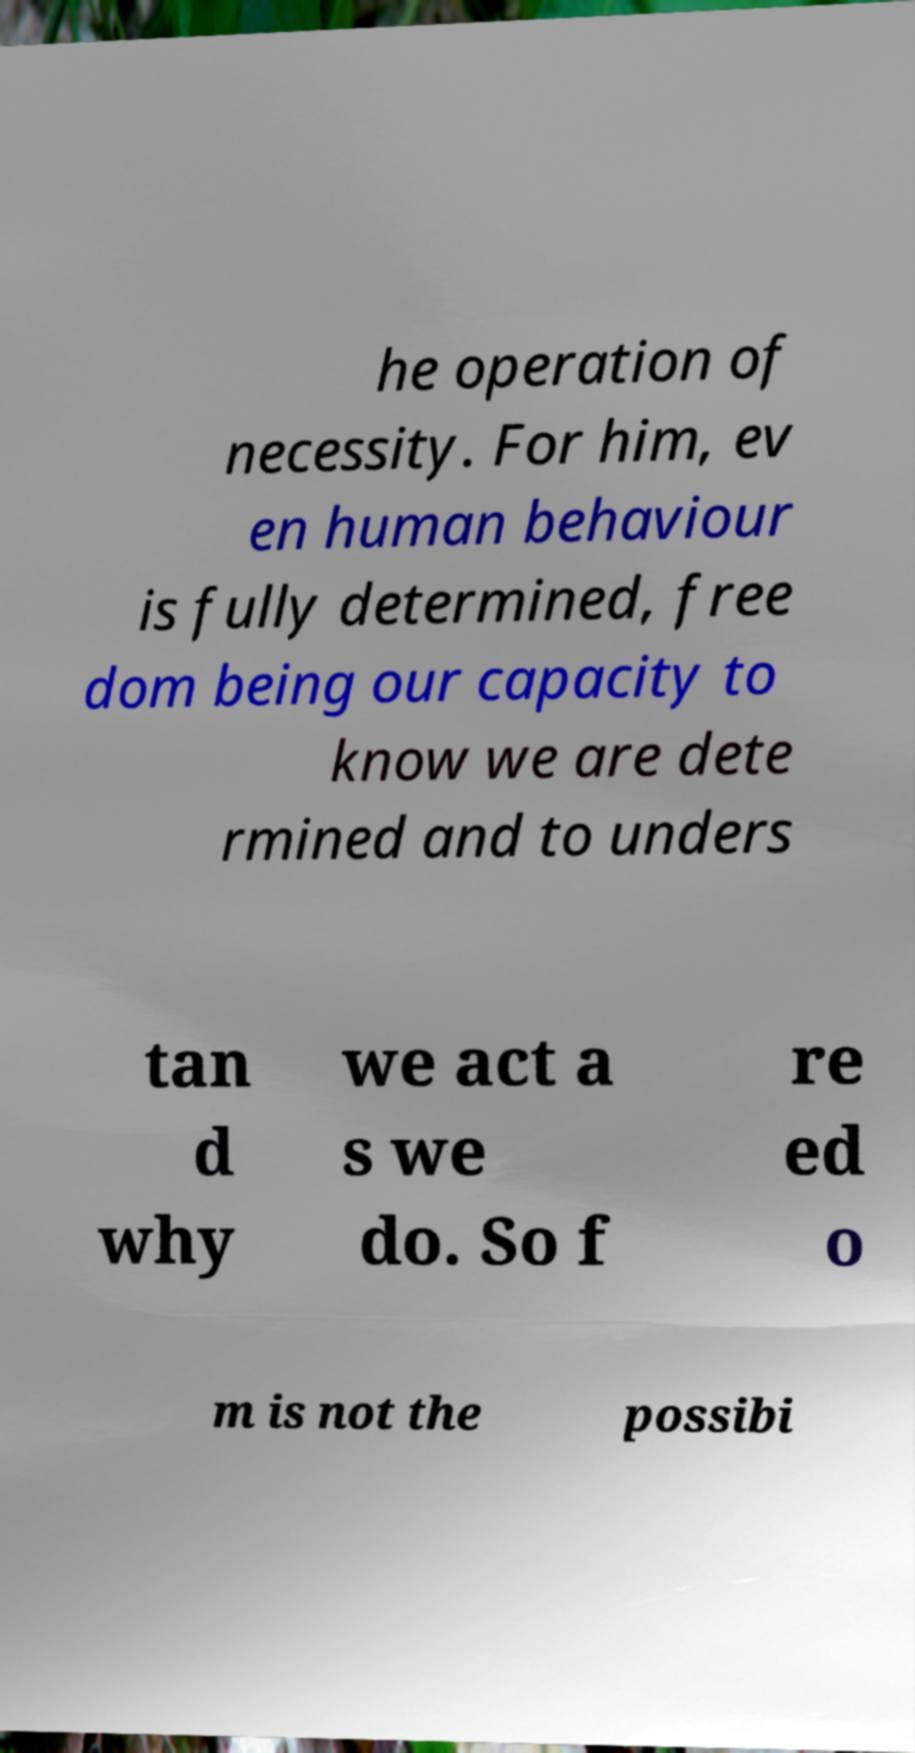Can you read and provide the text displayed in the image?This photo seems to have some interesting text. Can you extract and type it out for me? he operation of necessity. For him, ev en human behaviour is fully determined, free dom being our capacity to know we are dete rmined and to unders tan d why we act a s we do. So f re ed o m is not the possibi 